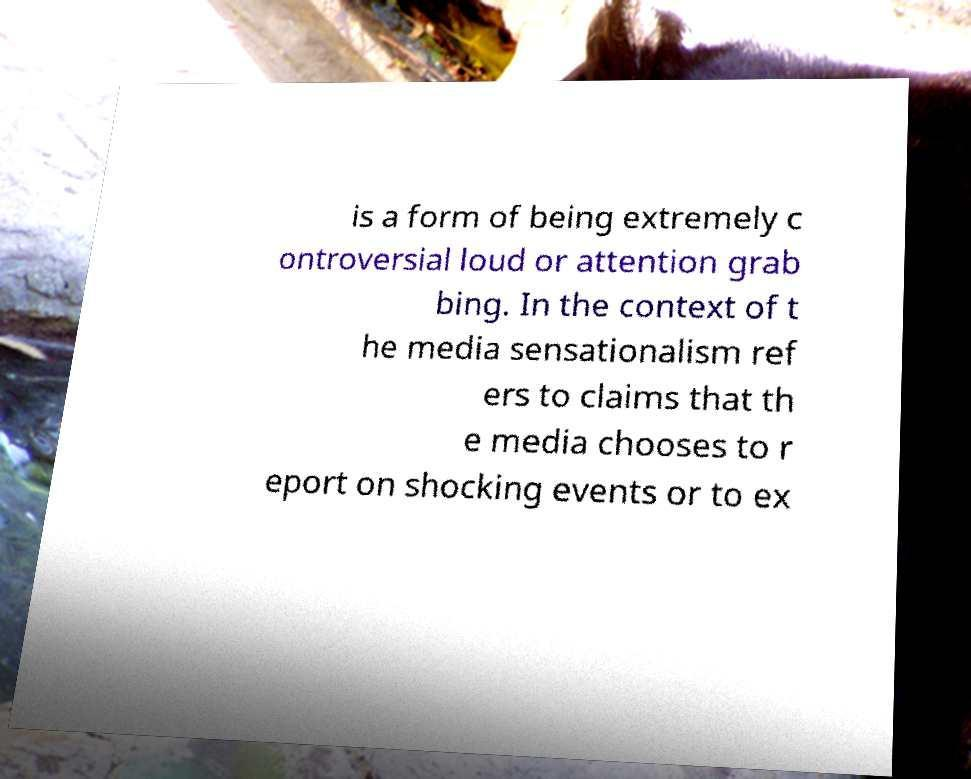What messages or text are displayed in this image? I need them in a readable, typed format. is a form of being extremely c ontroversial loud or attention grab bing. In the context of t he media sensationalism ref ers to claims that th e media chooses to r eport on shocking events or to ex 